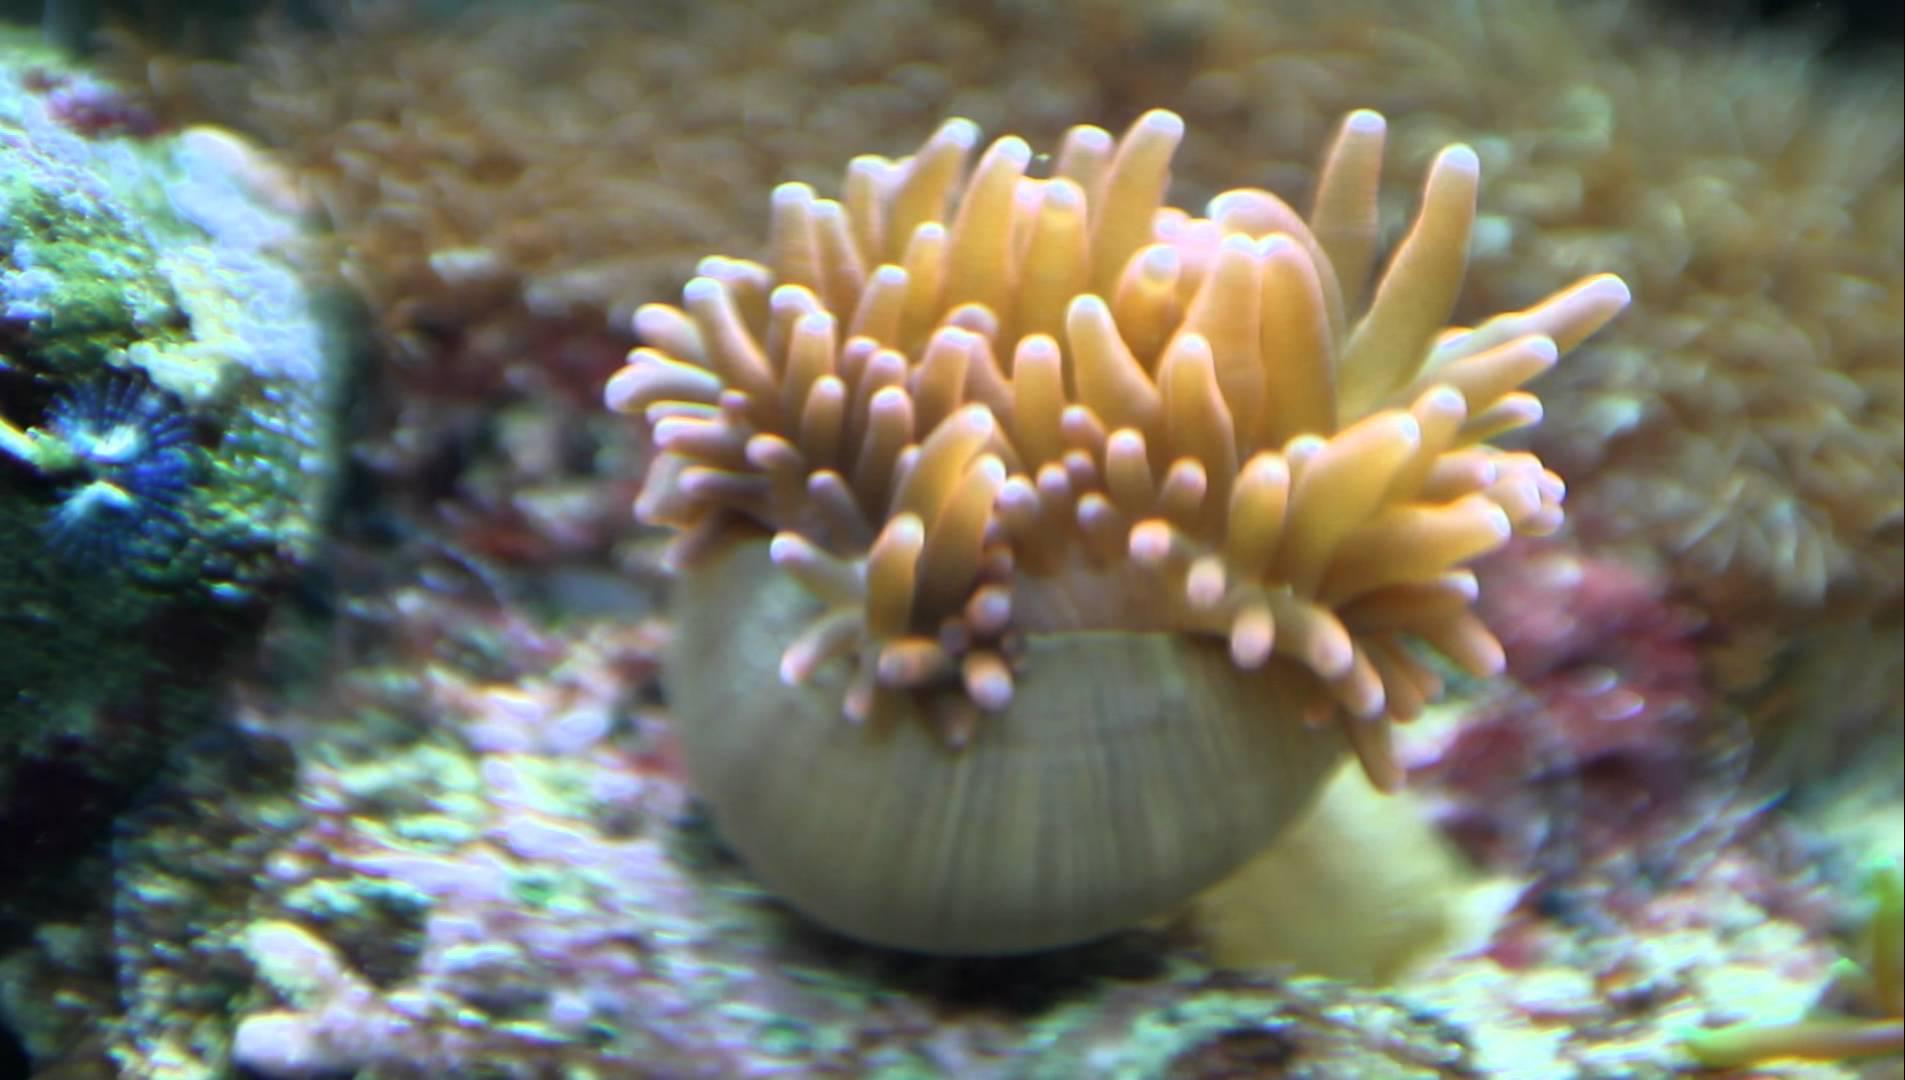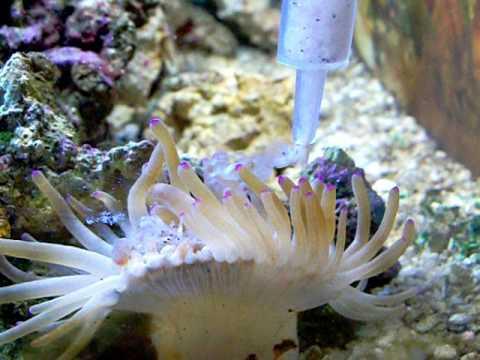The first image is the image on the left, the second image is the image on the right. For the images shown, is this caption "In at least one image there is at least one striped fish  swimming in corral." true? Answer yes or no. No. The first image is the image on the left, the second image is the image on the right. Analyze the images presented: Is the assertion "At least one fish with bold stripes is positioned over the tendrils of an anemone in the left image." valid? Answer yes or no. No. 